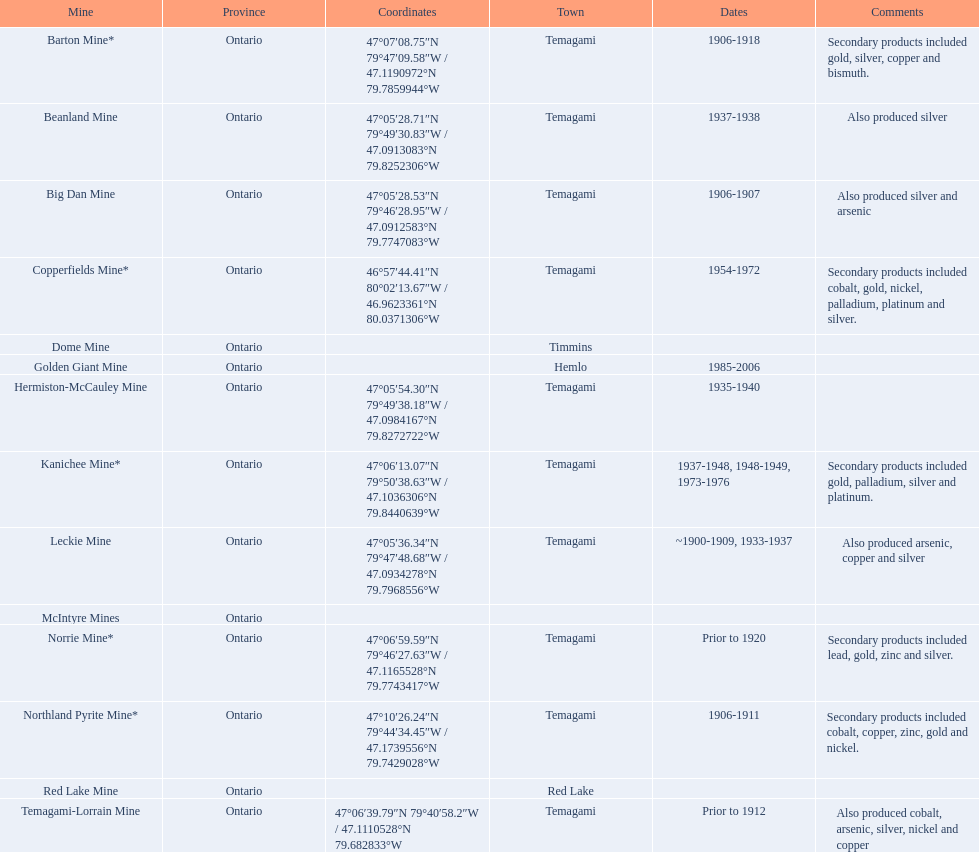What are all the mines with recorded dates? Barton Mine*, Beanland Mine, Big Dan Mine, Copperfields Mine*, Golden Giant Mine, Hermiston-McCauley Mine, Kanichee Mine*, Leckie Mine, Norrie Mine*, Northland Pyrite Mine*, Temagami-Lorrain Mine. Which of those dates involve the year the mine was shut down? 1906-1918, 1937-1938, 1906-1907, 1954-1972, 1985-2006, 1935-1940, 1937-1948, 1948-1949, 1973-1976, ~1900-1909, 1933-1937, 1906-1911. Which of those mines operated the longest? Golden Giant Mine. 